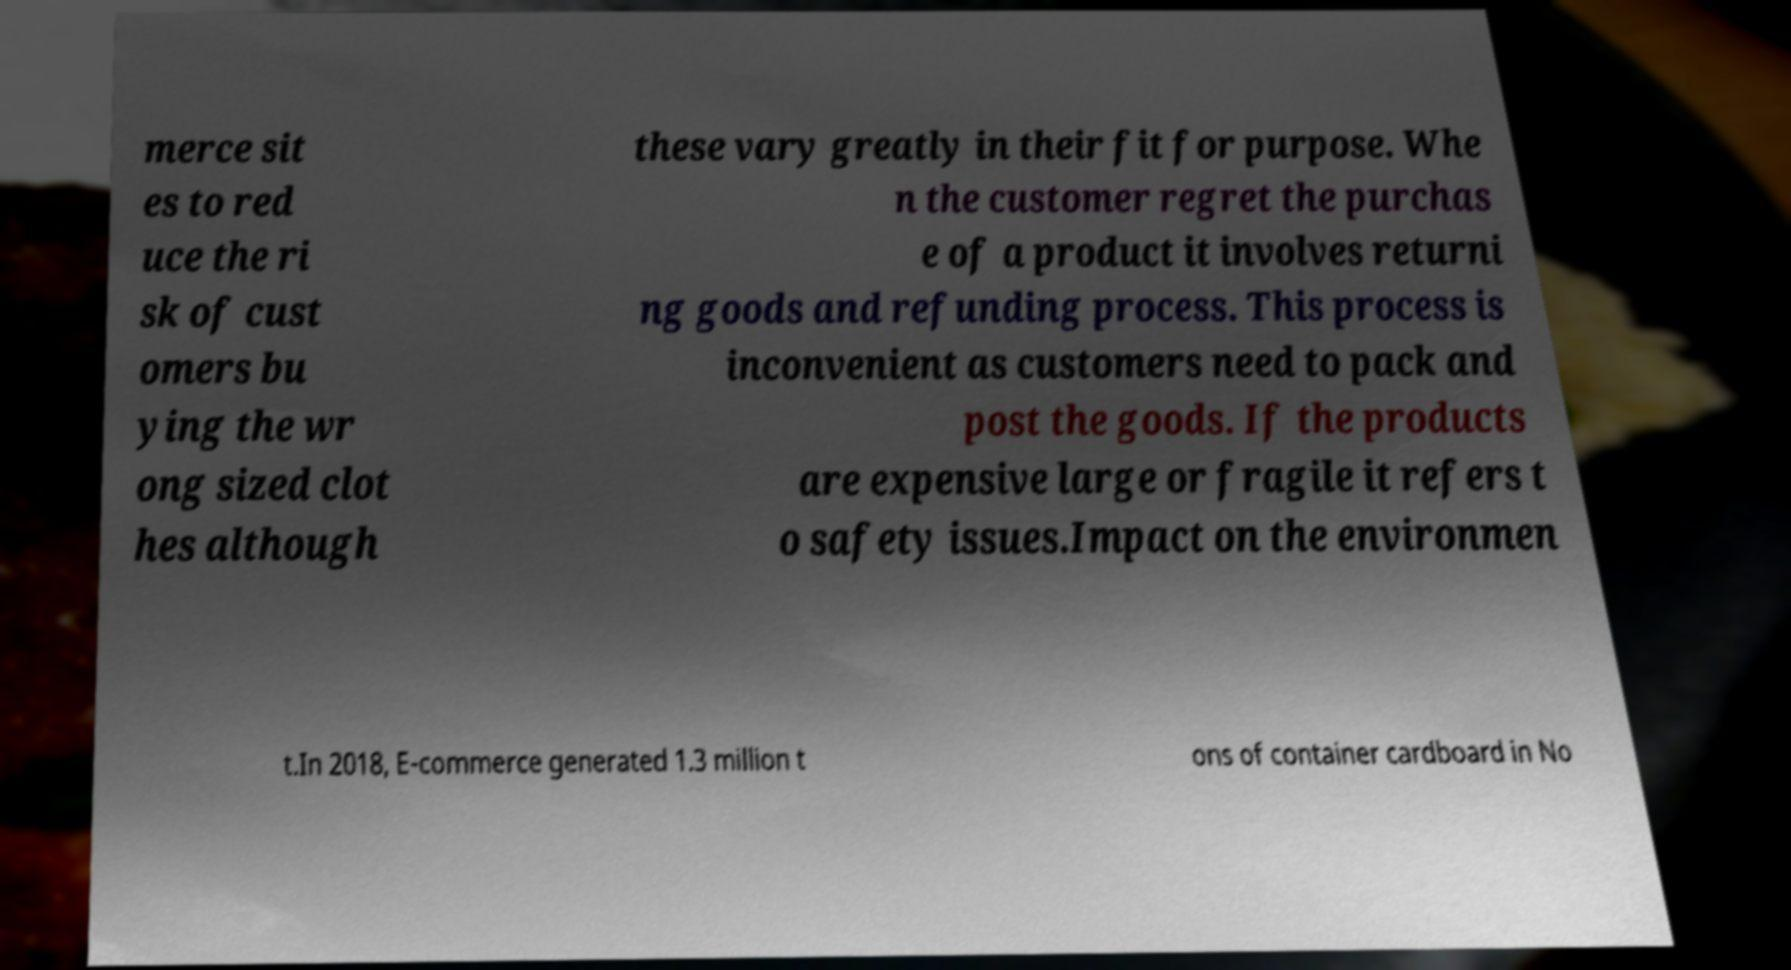Could you extract and type out the text from this image? merce sit es to red uce the ri sk of cust omers bu ying the wr ong sized clot hes although these vary greatly in their fit for purpose. Whe n the customer regret the purchas e of a product it involves returni ng goods and refunding process. This process is inconvenient as customers need to pack and post the goods. If the products are expensive large or fragile it refers t o safety issues.Impact on the environmen t.In 2018, E-commerce generated 1.3 million t ons of container cardboard in No 